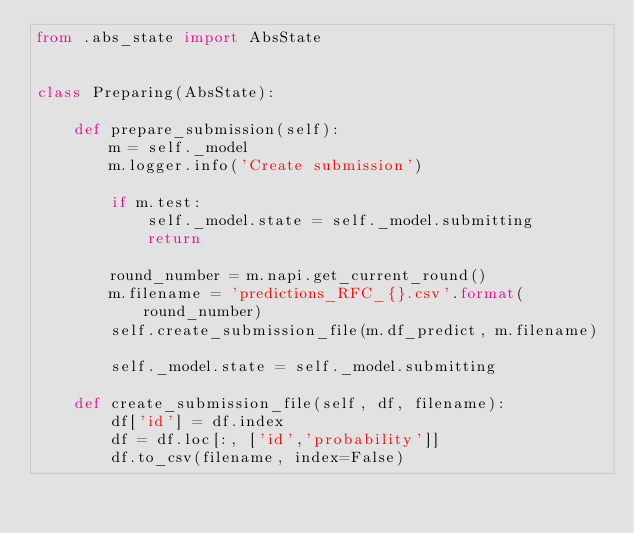<code> <loc_0><loc_0><loc_500><loc_500><_Python_>from .abs_state import AbsState


class Preparing(AbsState):

    def prepare_submission(self):
        m = self._model
        m.logger.info('Create submission')

        if m.test:
            self._model.state = self._model.submitting
            return

        round_number = m.napi.get_current_round()
        m.filename = 'predictions_RFC_{}.csv'.format(round_number)
        self.create_submission_file(m.df_predict, m.filename)

        self._model.state = self._model.submitting

    def create_submission_file(self, df, filename):
        df['id'] = df.index
        df = df.loc[:, ['id','probability']]
        df.to_csv(filename, index=False)
</code> 